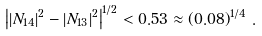<formula> <loc_0><loc_0><loc_500><loc_500>\left | | N _ { 1 4 } | ^ { 2 } - | N _ { 1 3 } | ^ { 2 } \right | ^ { 1 / 2 } < 0 . 5 3 \approx \left ( 0 . 0 8 \right ) ^ { 1 / 4 } \, .</formula> 